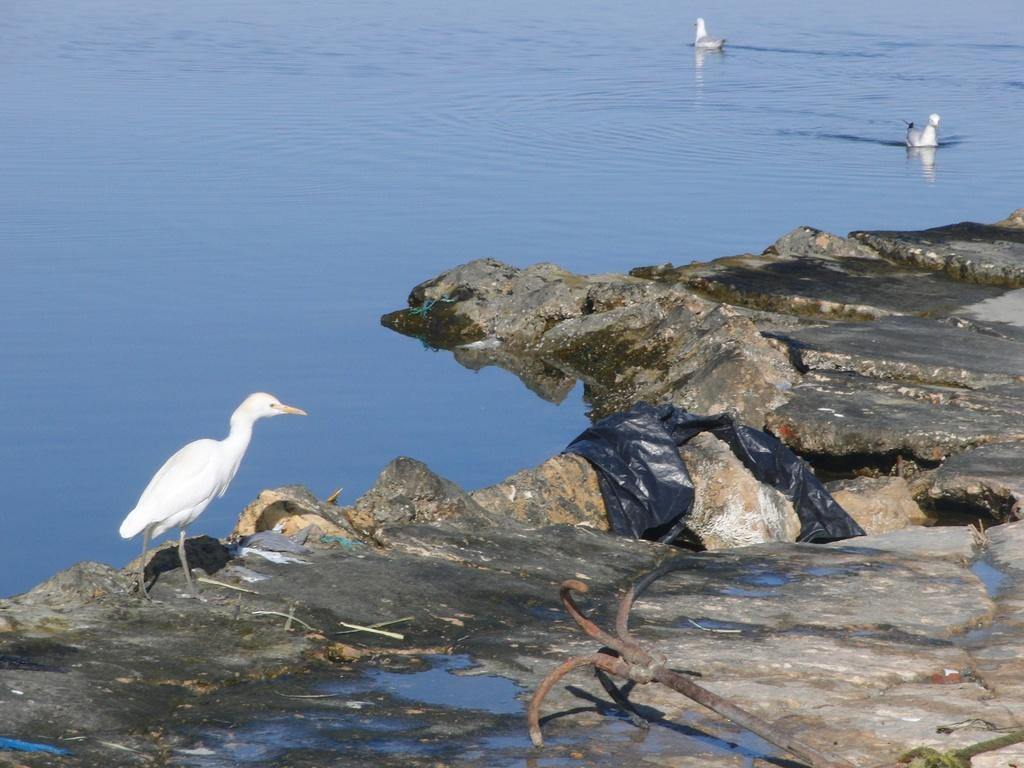Describe this image in one or two sentences. In this image we can see a rock and water. On the rock we can see a few objects and a bird. On the water we can see two birds. 